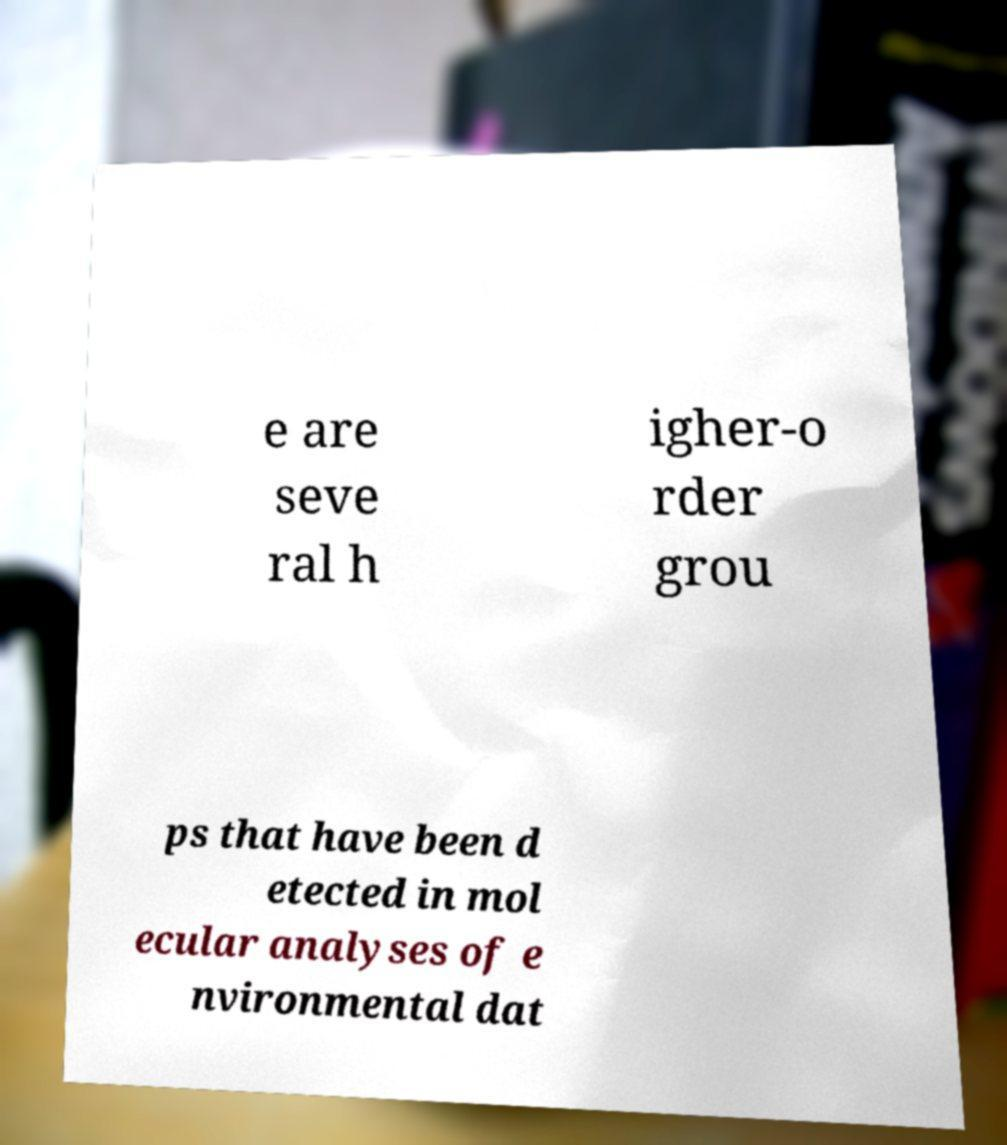Please identify and transcribe the text found in this image. e are seve ral h igher-o rder grou ps that have been d etected in mol ecular analyses of e nvironmental dat 